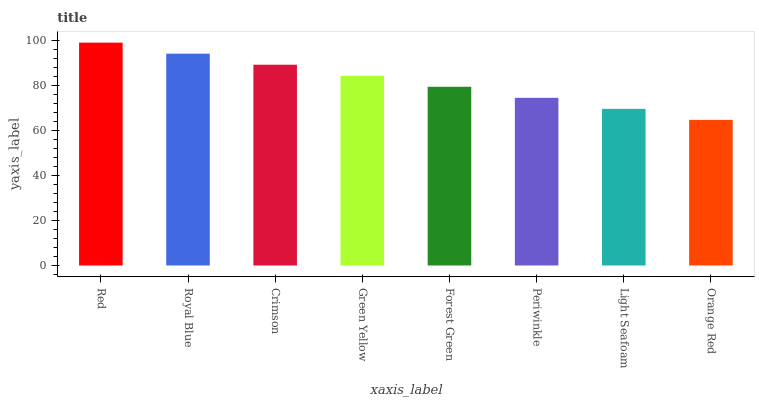Is Orange Red the minimum?
Answer yes or no. Yes. Is Red the maximum?
Answer yes or no. Yes. Is Royal Blue the minimum?
Answer yes or no. No. Is Royal Blue the maximum?
Answer yes or no. No. Is Red greater than Royal Blue?
Answer yes or no. Yes. Is Royal Blue less than Red?
Answer yes or no. Yes. Is Royal Blue greater than Red?
Answer yes or no. No. Is Red less than Royal Blue?
Answer yes or no. No. Is Green Yellow the high median?
Answer yes or no. Yes. Is Forest Green the low median?
Answer yes or no. Yes. Is Light Seafoam the high median?
Answer yes or no. No. Is Periwinkle the low median?
Answer yes or no. No. 